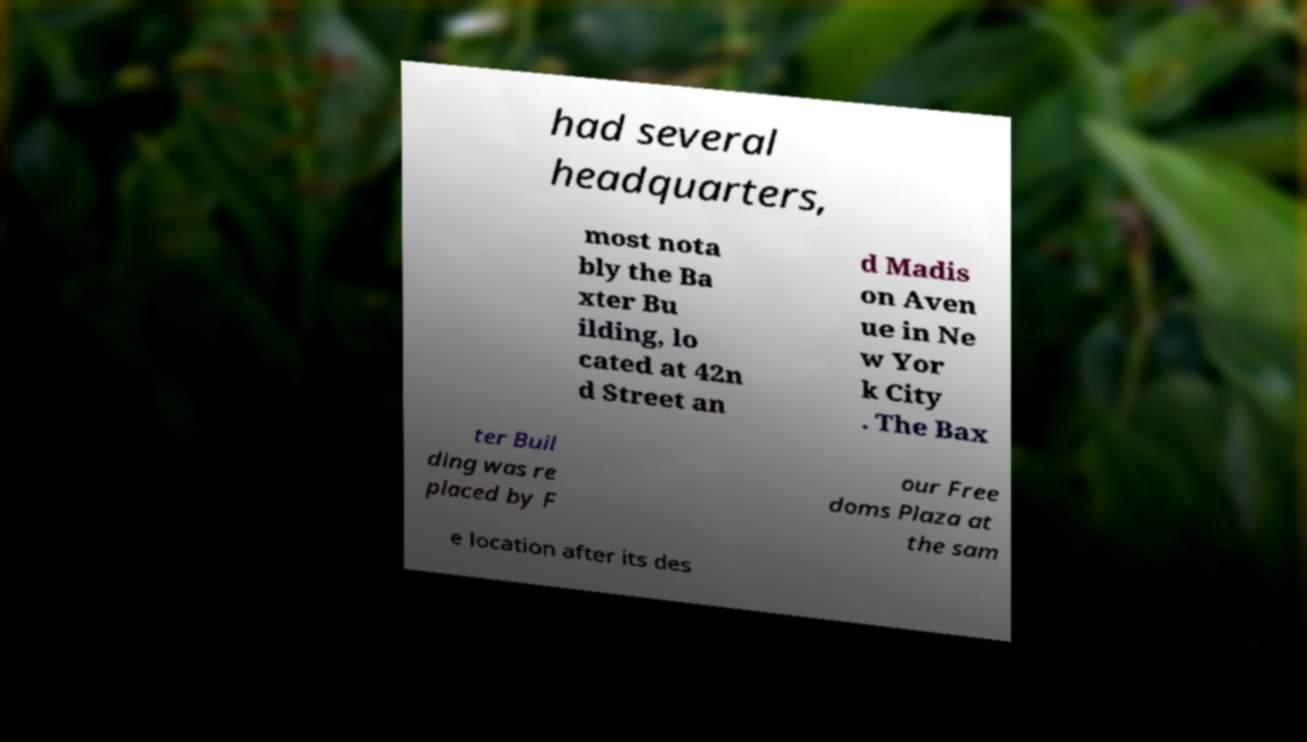What messages or text are displayed in this image? I need them in a readable, typed format. had several headquarters, most nota bly the Ba xter Bu ilding, lo cated at 42n d Street an d Madis on Aven ue in Ne w Yor k City . The Bax ter Buil ding was re placed by F our Free doms Plaza at the sam e location after its des 